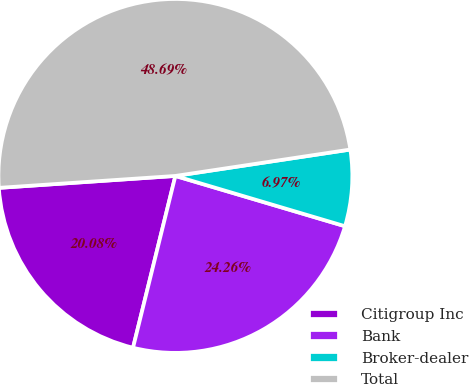Convert chart. <chart><loc_0><loc_0><loc_500><loc_500><pie_chart><fcel>Citigroup Inc<fcel>Bank<fcel>Broker-dealer<fcel>Total<nl><fcel>20.08%<fcel>24.26%<fcel>6.97%<fcel>48.69%<nl></chart> 